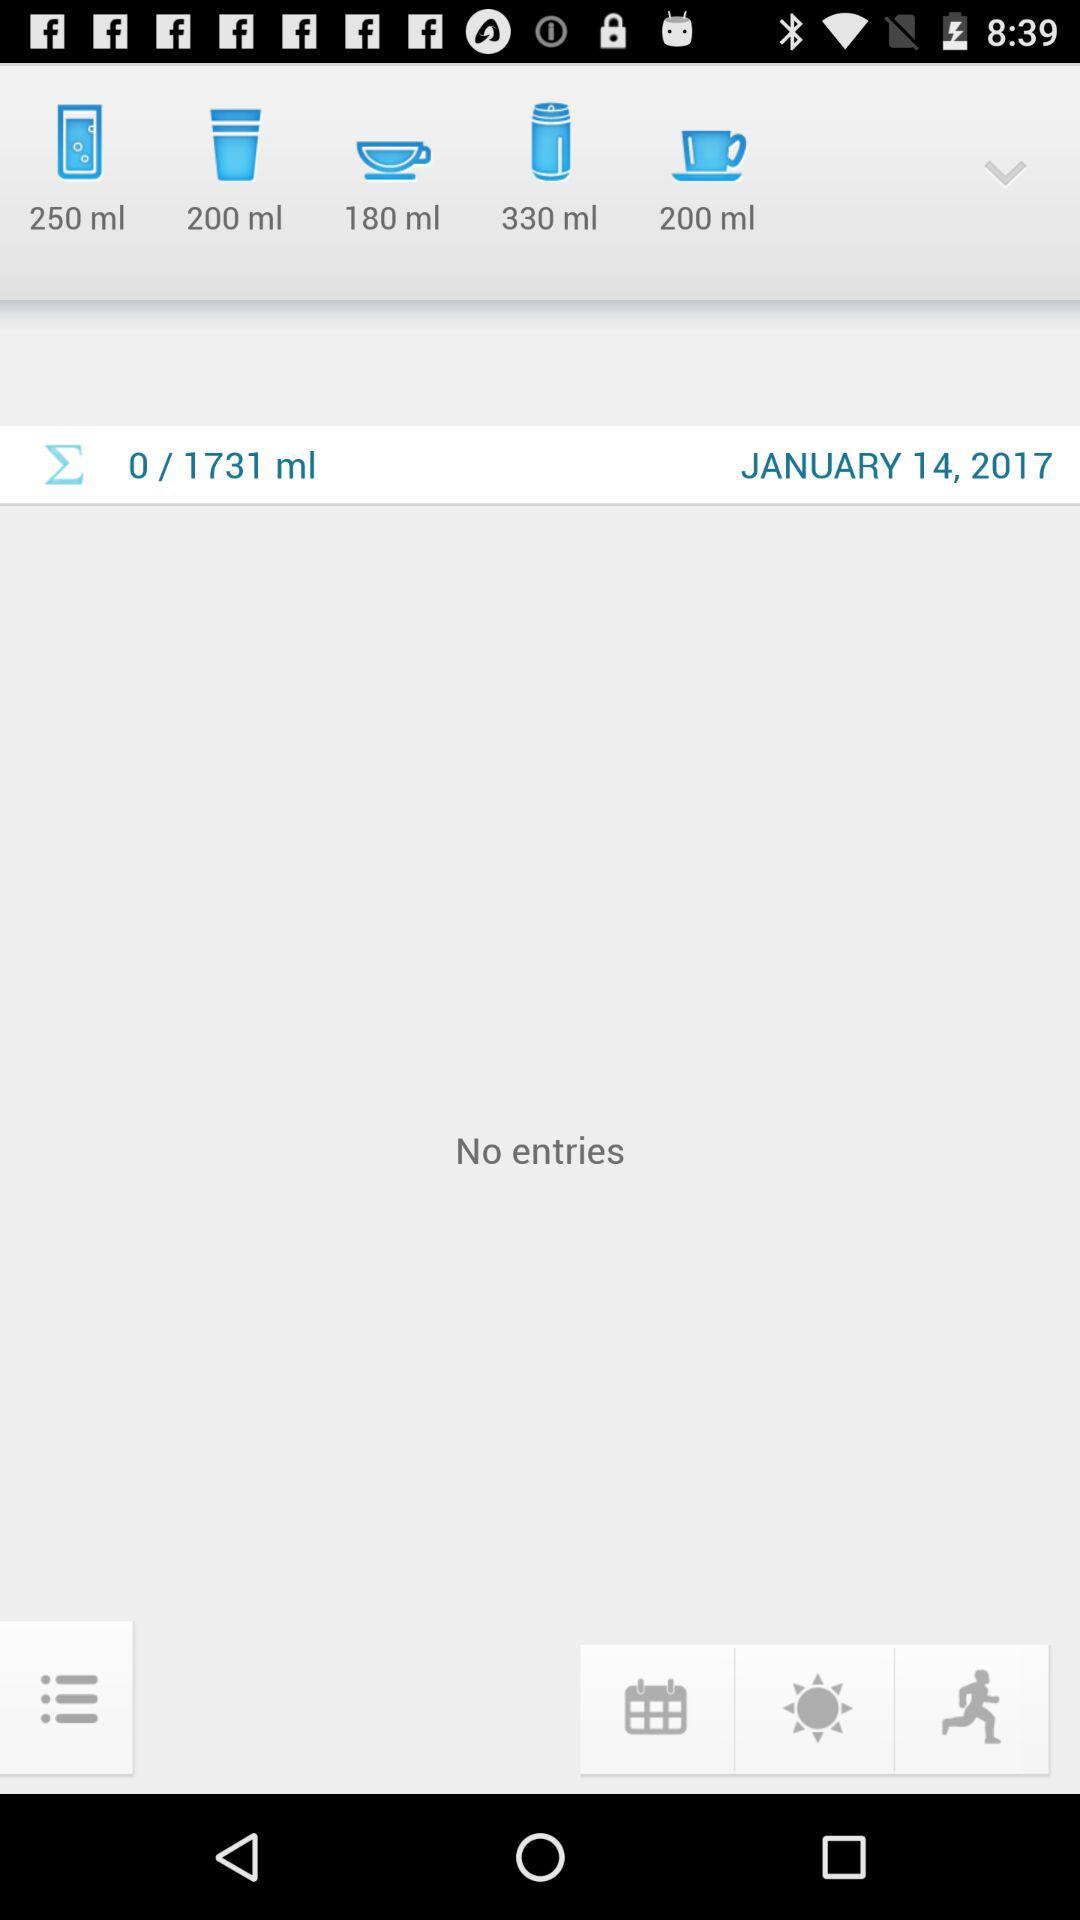What is the date?
Answer the question using a single word or phrase. The date is January 14 